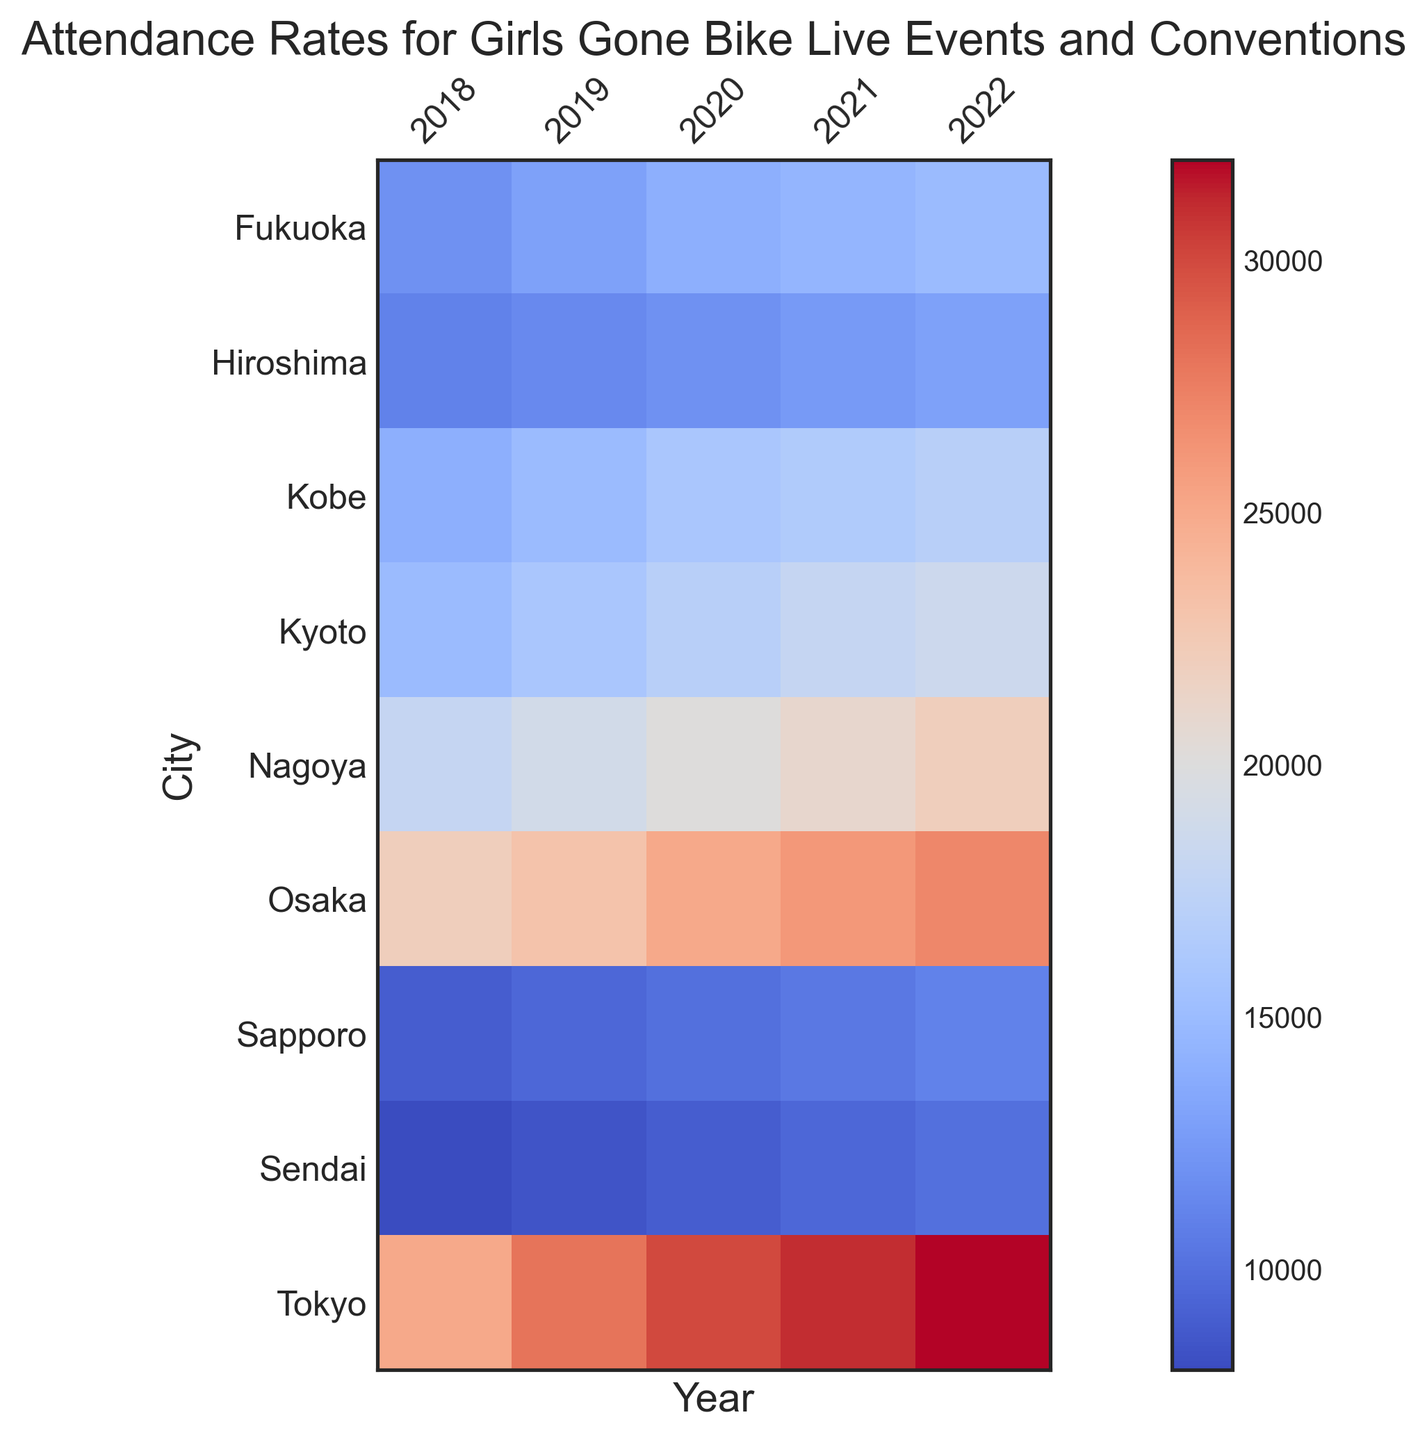Which city had the highest attendance in 2022? Look at the attendance values for each city in 2022. Tokyo has the highest attendance with 32,000.
Answer: Tokyo What was the average attendance for Kyoto over the years? Add up all the attendance values for Kyoto and then divide by the number of years. (15,000 + 16,000 + 17,000 + 18,000 + 18,500) / 5 = 16,900
Answer: 16,900 How did the attendance in Sapporo change from 2018 to 2022? Subtract the attendance in 2018 from the attendance in 2022. 11,000 - 9,000 = 2,000
Answer: Increased by 2,000 Which two cities had nearly equal attendance in 2020? Compare the attendance values for all cities in 2020 and find closely matching ones. Kobe and Hiroshima both had attendances of 16,000 and 12,000 respectively.
Answer: Kobe and Hiroshima How much did the attendance in Tokyo increase from 2018 to 2022? Subtract the attendance in 2018 from the attendance in 2022. 32,000 - 25,000 = 7,000
Answer: 7,000 Which city had the lowest attendance overall in any year? Find the minimum attendance value across all years and cities. The lowest attendance was in Sendai in 2018 with 8,000.
Answer: Sendai Which city's attendance showed the most significant increase between any two consecutive years? Compare the increases between consecutive years for all cities; the biggest rise appears between Tokyo 2019 and 2020. 30,000 - 28,000 = 2,000
Answer: Tokyo (2019-2020) In which year did Fukuoka's attendance first surpass 13,000? Track Fukuoka's attendance over the years until it exceeds 13,000. In 2019, the attendance was 13,000.
Answer: 2019 What is the color of the cell representing Osaka's attendance in 2021, and what does it signify? Look at the color and relative intensity for Osaka in 2021. The color is a lighter shade of red, denoting attendance around mid-to-high range.
Answer: Light red, mid-to-high range 